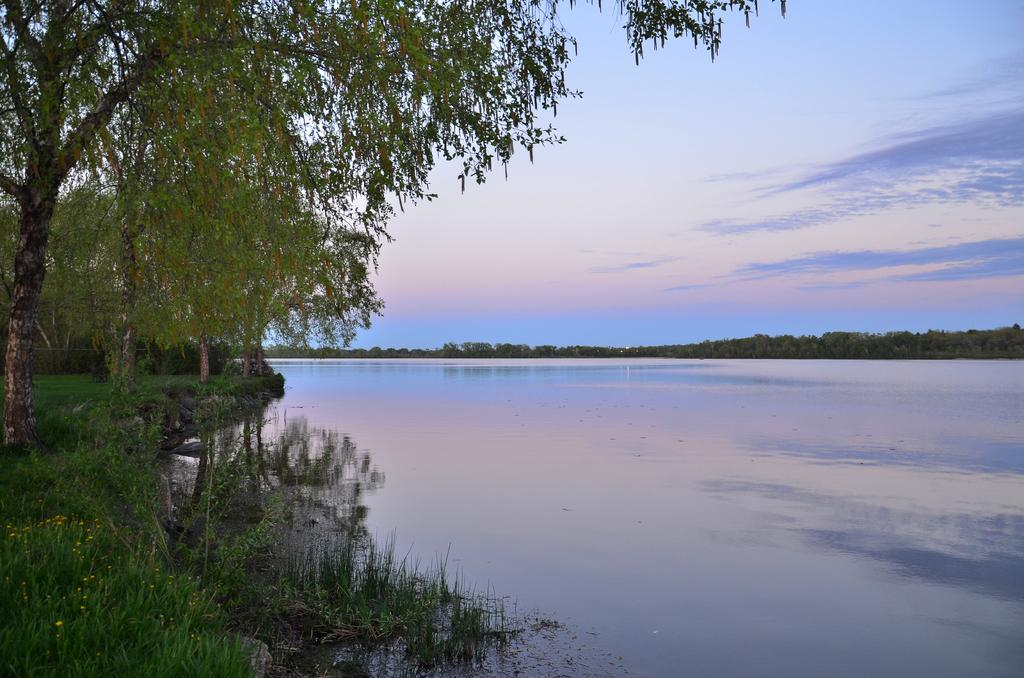What is one of the natural elements present in the image? There is water in the image. What type of vegetation can be seen in the image? There are trees and grass in the image. What can be seen in the background of the image? The sky is visible in the background of the image. How many oranges are hanging from the trees in the image? There are no oranges present in the image; it features trees and grass. Can you see an owl perched on one of the branches in the image? There is no owl visible in the image; it only contains trees, grass, water, and the sky. 